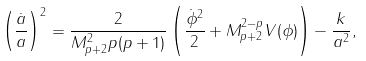Convert formula to latex. <formula><loc_0><loc_0><loc_500><loc_500>\left ( \frac { \dot { a } } { a } \right ) ^ { 2 } = \frac { 2 } { M _ { p + 2 } ^ { 2 } p ( p + 1 ) } \left ( \frac { \dot { \phi } ^ { 2 } } { 2 } + M _ { p + 2 } ^ { 2 - p } V ( \phi ) \right ) - \frac { k } { a ^ { 2 } } ,</formula> 